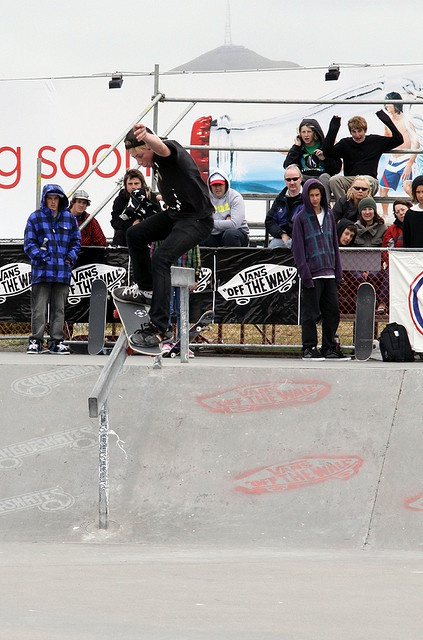Describe the objects in this image and their specific colors. I can see people in white, black, gray, brown, and darkgray tones, people in white, black, gray, and purple tones, people in white, black, navy, gray, and blue tones, people in white, lightgray, black, gray, and tan tones, and people in white, black, and gray tones in this image. 